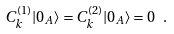<formula> <loc_0><loc_0><loc_500><loc_500>C ^ { ( 1 ) } _ { k } | 0 _ { A } \rangle = C ^ { ( 2 ) } _ { k } | 0 _ { A } \rangle = 0 \ .</formula> 